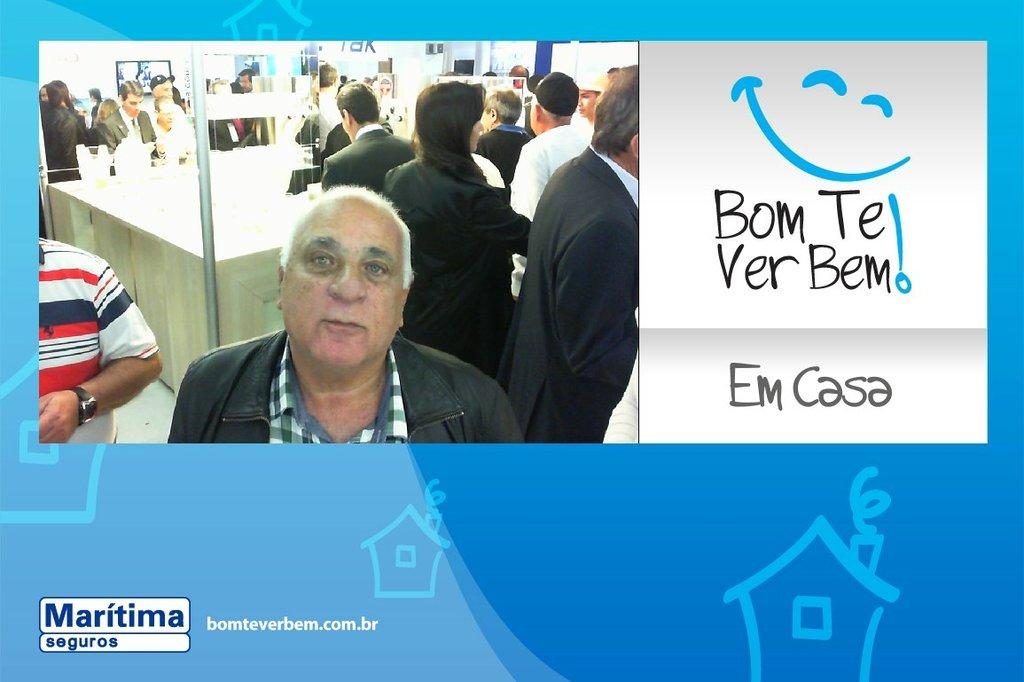<image>
Describe the image concisely. the word casa is next to the man 